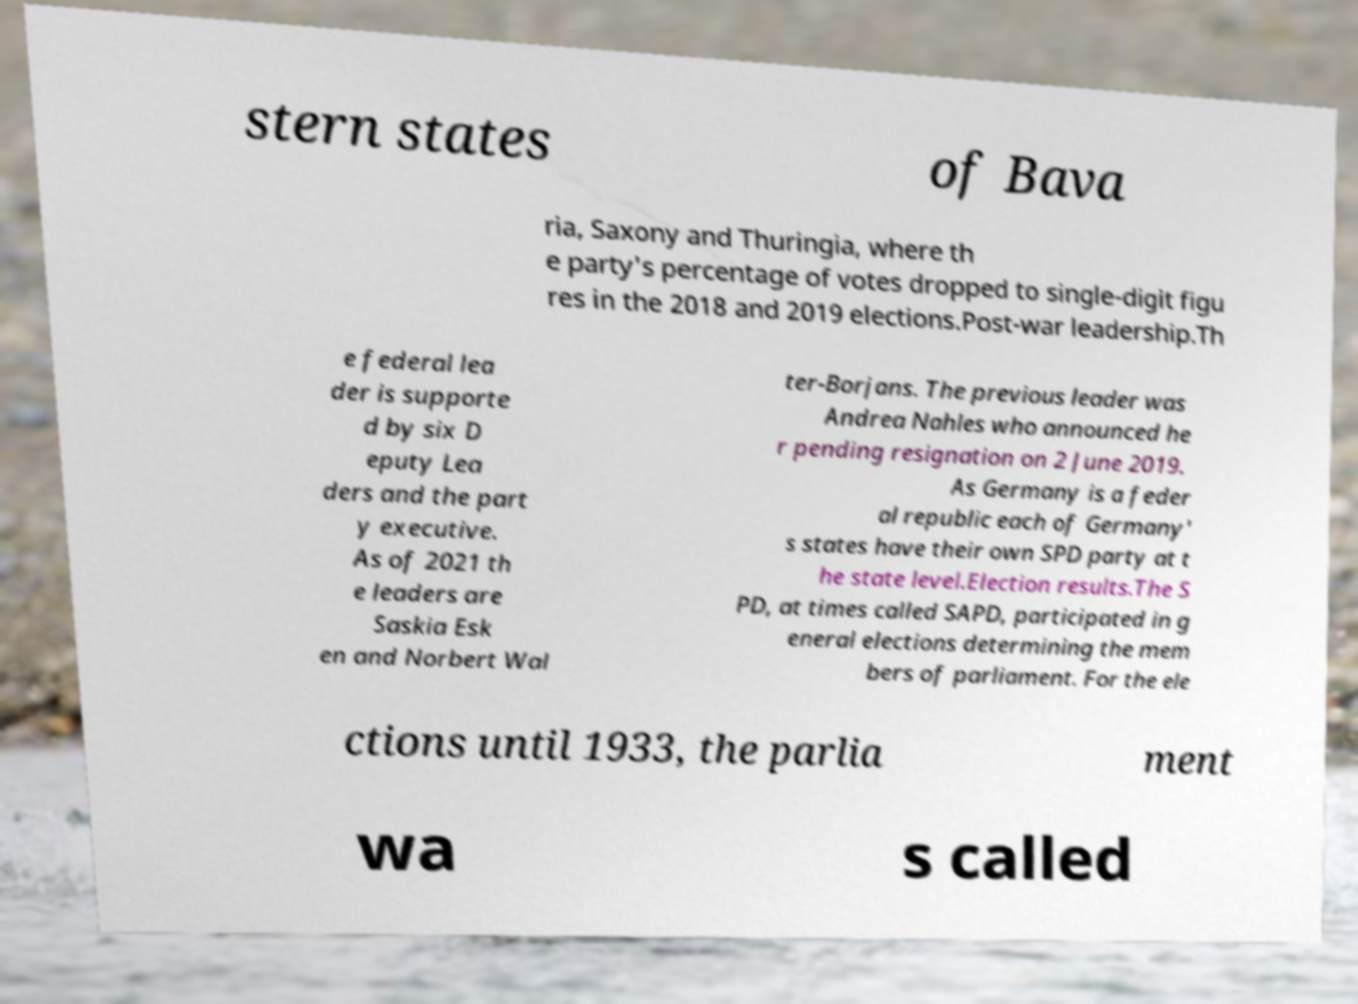Can you accurately transcribe the text from the provided image for me? stern states of Bava ria, Saxony and Thuringia, where th e party's percentage of votes dropped to single-digit figu res in the 2018 and 2019 elections.Post-war leadership.Th e federal lea der is supporte d by six D eputy Lea ders and the part y executive. As of 2021 th e leaders are Saskia Esk en and Norbert Wal ter-Borjans. The previous leader was Andrea Nahles who announced he r pending resignation on 2 June 2019. As Germany is a feder al republic each of Germany' s states have their own SPD party at t he state level.Election results.The S PD, at times called SAPD, participated in g eneral elections determining the mem bers of parliament. For the ele ctions until 1933, the parlia ment wa s called 